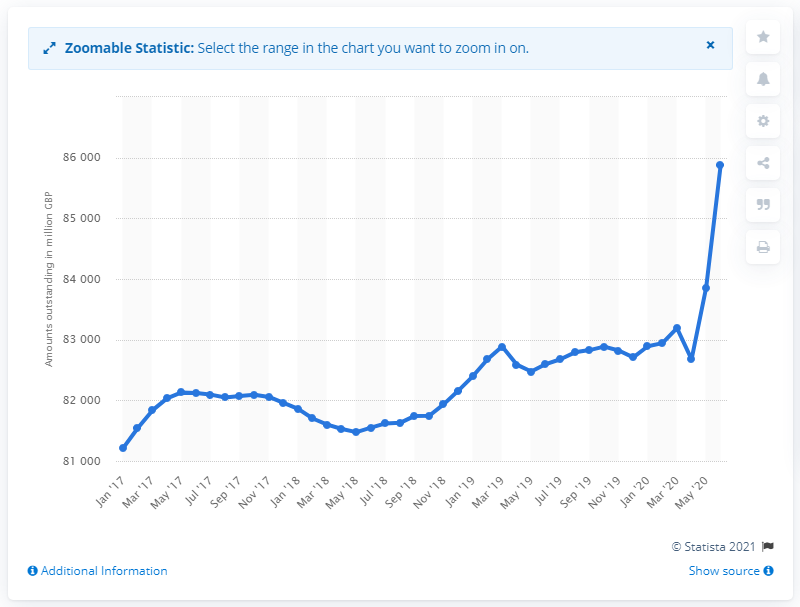Identify some key points in this picture. In June 2020, the value of outstanding notes and coins in circulation in the UK was 858,830. 